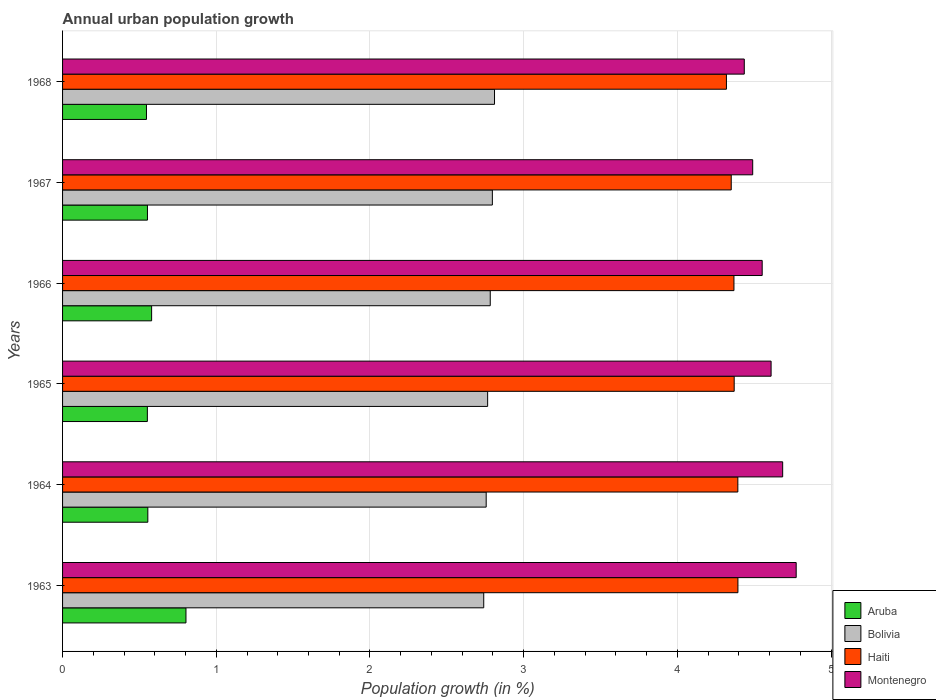Are the number of bars per tick equal to the number of legend labels?
Give a very brief answer. Yes. How many bars are there on the 6th tick from the top?
Make the answer very short. 4. What is the label of the 3rd group of bars from the top?
Give a very brief answer. 1966. What is the percentage of urban population growth in Aruba in 1966?
Ensure brevity in your answer.  0.58. Across all years, what is the maximum percentage of urban population growth in Aruba?
Ensure brevity in your answer.  0.8. Across all years, what is the minimum percentage of urban population growth in Bolivia?
Offer a very short reply. 2.74. In which year was the percentage of urban population growth in Aruba maximum?
Provide a succinct answer. 1963. In which year was the percentage of urban population growth in Haiti minimum?
Offer a very short reply. 1968. What is the total percentage of urban population growth in Montenegro in the graph?
Provide a short and direct response. 27.54. What is the difference between the percentage of urban population growth in Montenegro in 1964 and that in 1967?
Ensure brevity in your answer.  0.2. What is the difference between the percentage of urban population growth in Haiti in 1966 and the percentage of urban population growth in Montenegro in 1965?
Offer a very short reply. -0.24. What is the average percentage of urban population growth in Aruba per year?
Your answer should be very brief. 0.6. In the year 1968, what is the difference between the percentage of urban population growth in Aruba and percentage of urban population growth in Haiti?
Make the answer very short. -3.77. What is the ratio of the percentage of urban population growth in Montenegro in 1965 to that in 1966?
Your response must be concise. 1.01. Is the percentage of urban population growth in Bolivia in 1965 less than that in 1966?
Make the answer very short. Yes. What is the difference between the highest and the second highest percentage of urban population growth in Montenegro?
Offer a very short reply. 0.09. What is the difference between the highest and the lowest percentage of urban population growth in Aruba?
Provide a short and direct response. 0.26. In how many years, is the percentage of urban population growth in Bolivia greater than the average percentage of urban population growth in Bolivia taken over all years?
Your answer should be compact. 3. Is the sum of the percentage of urban population growth in Montenegro in 1965 and 1966 greater than the maximum percentage of urban population growth in Aruba across all years?
Ensure brevity in your answer.  Yes. Is it the case that in every year, the sum of the percentage of urban population growth in Aruba and percentage of urban population growth in Montenegro is greater than the sum of percentage of urban population growth in Haiti and percentage of urban population growth in Bolivia?
Your answer should be compact. No. What does the 1st bar from the top in 1963 represents?
Make the answer very short. Montenegro. What does the 3rd bar from the bottom in 1968 represents?
Provide a succinct answer. Haiti. Is it the case that in every year, the sum of the percentage of urban population growth in Haiti and percentage of urban population growth in Bolivia is greater than the percentage of urban population growth in Montenegro?
Your answer should be very brief. Yes. How many bars are there?
Provide a succinct answer. 24. Are all the bars in the graph horizontal?
Keep it short and to the point. Yes. How many years are there in the graph?
Your answer should be very brief. 6. What is the difference between two consecutive major ticks on the X-axis?
Give a very brief answer. 1. Does the graph contain any zero values?
Your response must be concise. No. Does the graph contain grids?
Your answer should be very brief. Yes. Where does the legend appear in the graph?
Provide a succinct answer. Bottom right. What is the title of the graph?
Provide a short and direct response. Annual urban population growth. What is the label or title of the X-axis?
Ensure brevity in your answer.  Population growth (in %). What is the label or title of the Y-axis?
Offer a terse response. Years. What is the Population growth (in %) in Aruba in 1963?
Make the answer very short. 0.8. What is the Population growth (in %) of Bolivia in 1963?
Offer a terse response. 2.74. What is the Population growth (in %) in Haiti in 1963?
Provide a short and direct response. 4.39. What is the Population growth (in %) in Montenegro in 1963?
Make the answer very short. 4.77. What is the Population growth (in %) of Aruba in 1964?
Give a very brief answer. 0.55. What is the Population growth (in %) of Bolivia in 1964?
Provide a short and direct response. 2.76. What is the Population growth (in %) in Haiti in 1964?
Make the answer very short. 4.39. What is the Population growth (in %) of Montenegro in 1964?
Make the answer very short. 4.69. What is the Population growth (in %) in Aruba in 1965?
Make the answer very short. 0.55. What is the Population growth (in %) in Bolivia in 1965?
Provide a short and direct response. 2.77. What is the Population growth (in %) in Haiti in 1965?
Give a very brief answer. 4.37. What is the Population growth (in %) of Montenegro in 1965?
Offer a terse response. 4.61. What is the Population growth (in %) of Aruba in 1966?
Offer a terse response. 0.58. What is the Population growth (in %) in Bolivia in 1966?
Offer a terse response. 2.78. What is the Population growth (in %) of Haiti in 1966?
Make the answer very short. 4.37. What is the Population growth (in %) of Montenegro in 1966?
Ensure brevity in your answer.  4.55. What is the Population growth (in %) of Aruba in 1967?
Ensure brevity in your answer.  0.55. What is the Population growth (in %) in Bolivia in 1967?
Your answer should be very brief. 2.8. What is the Population growth (in %) of Haiti in 1967?
Your response must be concise. 4.35. What is the Population growth (in %) in Montenegro in 1967?
Offer a very short reply. 4.49. What is the Population growth (in %) of Aruba in 1968?
Ensure brevity in your answer.  0.55. What is the Population growth (in %) in Bolivia in 1968?
Your answer should be compact. 2.81. What is the Population growth (in %) in Haiti in 1968?
Your answer should be very brief. 4.32. What is the Population growth (in %) of Montenegro in 1968?
Your answer should be very brief. 4.44. Across all years, what is the maximum Population growth (in %) in Aruba?
Offer a terse response. 0.8. Across all years, what is the maximum Population growth (in %) of Bolivia?
Keep it short and to the point. 2.81. Across all years, what is the maximum Population growth (in %) of Haiti?
Provide a succinct answer. 4.39. Across all years, what is the maximum Population growth (in %) in Montenegro?
Your answer should be compact. 4.77. Across all years, what is the minimum Population growth (in %) of Aruba?
Ensure brevity in your answer.  0.55. Across all years, what is the minimum Population growth (in %) in Bolivia?
Give a very brief answer. 2.74. Across all years, what is the minimum Population growth (in %) in Haiti?
Your response must be concise. 4.32. Across all years, what is the minimum Population growth (in %) in Montenegro?
Give a very brief answer. 4.44. What is the total Population growth (in %) of Aruba in the graph?
Your response must be concise. 3.59. What is the total Population growth (in %) in Bolivia in the graph?
Ensure brevity in your answer.  16.65. What is the total Population growth (in %) of Haiti in the graph?
Offer a very short reply. 26.19. What is the total Population growth (in %) of Montenegro in the graph?
Your answer should be compact. 27.54. What is the difference between the Population growth (in %) of Aruba in 1963 and that in 1964?
Your response must be concise. 0.25. What is the difference between the Population growth (in %) in Bolivia in 1963 and that in 1964?
Your answer should be very brief. -0.02. What is the difference between the Population growth (in %) in Haiti in 1963 and that in 1964?
Your answer should be compact. 0. What is the difference between the Population growth (in %) in Montenegro in 1963 and that in 1964?
Provide a succinct answer. 0.09. What is the difference between the Population growth (in %) in Aruba in 1963 and that in 1965?
Provide a short and direct response. 0.25. What is the difference between the Population growth (in %) in Bolivia in 1963 and that in 1965?
Keep it short and to the point. -0.03. What is the difference between the Population growth (in %) in Haiti in 1963 and that in 1965?
Ensure brevity in your answer.  0.02. What is the difference between the Population growth (in %) in Montenegro in 1963 and that in 1965?
Your answer should be compact. 0.16. What is the difference between the Population growth (in %) of Aruba in 1963 and that in 1966?
Give a very brief answer. 0.22. What is the difference between the Population growth (in %) of Bolivia in 1963 and that in 1966?
Make the answer very short. -0.04. What is the difference between the Population growth (in %) of Haiti in 1963 and that in 1966?
Keep it short and to the point. 0.03. What is the difference between the Population growth (in %) in Montenegro in 1963 and that in 1966?
Provide a short and direct response. 0.22. What is the difference between the Population growth (in %) of Aruba in 1963 and that in 1967?
Provide a short and direct response. 0.25. What is the difference between the Population growth (in %) of Bolivia in 1963 and that in 1967?
Offer a terse response. -0.06. What is the difference between the Population growth (in %) in Haiti in 1963 and that in 1967?
Give a very brief answer. 0.04. What is the difference between the Population growth (in %) in Montenegro in 1963 and that in 1967?
Offer a very short reply. 0.28. What is the difference between the Population growth (in %) of Aruba in 1963 and that in 1968?
Keep it short and to the point. 0.26. What is the difference between the Population growth (in %) of Bolivia in 1963 and that in 1968?
Provide a succinct answer. -0.07. What is the difference between the Population growth (in %) of Haiti in 1963 and that in 1968?
Your answer should be very brief. 0.07. What is the difference between the Population growth (in %) of Montenegro in 1963 and that in 1968?
Offer a terse response. 0.34. What is the difference between the Population growth (in %) of Aruba in 1964 and that in 1965?
Provide a short and direct response. 0. What is the difference between the Population growth (in %) in Bolivia in 1964 and that in 1965?
Provide a succinct answer. -0.01. What is the difference between the Population growth (in %) of Haiti in 1964 and that in 1965?
Make the answer very short. 0.02. What is the difference between the Population growth (in %) in Montenegro in 1964 and that in 1965?
Ensure brevity in your answer.  0.08. What is the difference between the Population growth (in %) of Aruba in 1964 and that in 1966?
Provide a succinct answer. -0.02. What is the difference between the Population growth (in %) in Bolivia in 1964 and that in 1966?
Your answer should be very brief. -0.03. What is the difference between the Population growth (in %) of Haiti in 1964 and that in 1966?
Your response must be concise. 0.03. What is the difference between the Population growth (in %) of Montenegro in 1964 and that in 1966?
Provide a short and direct response. 0.13. What is the difference between the Population growth (in %) in Aruba in 1964 and that in 1967?
Offer a very short reply. 0. What is the difference between the Population growth (in %) in Bolivia in 1964 and that in 1967?
Ensure brevity in your answer.  -0.04. What is the difference between the Population growth (in %) in Haiti in 1964 and that in 1967?
Make the answer very short. 0.04. What is the difference between the Population growth (in %) of Montenegro in 1964 and that in 1967?
Ensure brevity in your answer.  0.2. What is the difference between the Population growth (in %) in Aruba in 1964 and that in 1968?
Your answer should be very brief. 0.01. What is the difference between the Population growth (in %) of Bolivia in 1964 and that in 1968?
Provide a succinct answer. -0.05. What is the difference between the Population growth (in %) of Haiti in 1964 and that in 1968?
Provide a short and direct response. 0.07. What is the difference between the Population growth (in %) of Montenegro in 1964 and that in 1968?
Offer a very short reply. 0.25. What is the difference between the Population growth (in %) in Aruba in 1965 and that in 1966?
Offer a terse response. -0.03. What is the difference between the Population growth (in %) of Bolivia in 1965 and that in 1966?
Offer a terse response. -0.02. What is the difference between the Population growth (in %) of Haiti in 1965 and that in 1966?
Your answer should be compact. 0. What is the difference between the Population growth (in %) in Montenegro in 1965 and that in 1966?
Keep it short and to the point. 0.06. What is the difference between the Population growth (in %) in Aruba in 1965 and that in 1967?
Keep it short and to the point. -0. What is the difference between the Population growth (in %) of Bolivia in 1965 and that in 1967?
Ensure brevity in your answer.  -0.03. What is the difference between the Population growth (in %) in Haiti in 1965 and that in 1967?
Your response must be concise. 0.02. What is the difference between the Population growth (in %) of Montenegro in 1965 and that in 1967?
Your response must be concise. 0.12. What is the difference between the Population growth (in %) in Aruba in 1965 and that in 1968?
Your answer should be compact. 0.01. What is the difference between the Population growth (in %) in Bolivia in 1965 and that in 1968?
Your answer should be compact. -0.04. What is the difference between the Population growth (in %) of Haiti in 1965 and that in 1968?
Ensure brevity in your answer.  0.05. What is the difference between the Population growth (in %) in Montenegro in 1965 and that in 1968?
Give a very brief answer. 0.17. What is the difference between the Population growth (in %) in Aruba in 1966 and that in 1967?
Provide a short and direct response. 0.03. What is the difference between the Population growth (in %) in Bolivia in 1966 and that in 1967?
Your answer should be compact. -0.01. What is the difference between the Population growth (in %) of Haiti in 1966 and that in 1967?
Ensure brevity in your answer.  0.02. What is the difference between the Population growth (in %) of Montenegro in 1966 and that in 1967?
Make the answer very short. 0.06. What is the difference between the Population growth (in %) in Aruba in 1966 and that in 1968?
Your response must be concise. 0.03. What is the difference between the Population growth (in %) in Bolivia in 1966 and that in 1968?
Ensure brevity in your answer.  -0.03. What is the difference between the Population growth (in %) in Haiti in 1966 and that in 1968?
Provide a succinct answer. 0.05. What is the difference between the Population growth (in %) in Montenegro in 1966 and that in 1968?
Your answer should be compact. 0.12. What is the difference between the Population growth (in %) of Aruba in 1967 and that in 1968?
Offer a terse response. 0.01. What is the difference between the Population growth (in %) in Bolivia in 1967 and that in 1968?
Provide a succinct answer. -0.01. What is the difference between the Population growth (in %) in Haiti in 1967 and that in 1968?
Keep it short and to the point. 0.03. What is the difference between the Population growth (in %) of Montenegro in 1967 and that in 1968?
Ensure brevity in your answer.  0.05. What is the difference between the Population growth (in %) in Aruba in 1963 and the Population growth (in %) in Bolivia in 1964?
Your response must be concise. -1.95. What is the difference between the Population growth (in %) in Aruba in 1963 and the Population growth (in %) in Haiti in 1964?
Provide a short and direct response. -3.59. What is the difference between the Population growth (in %) of Aruba in 1963 and the Population growth (in %) of Montenegro in 1964?
Provide a short and direct response. -3.88. What is the difference between the Population growth (in %) in Bolivia in 1963 and the Population growth (in %) in Haiti in 1964?
Give a very brief answer. -1.65. What is the difference between the Population growth (in %) of Bolivia in 1963 and the Population growth (in %) of Montenegro in 1964?
Provide a succinct answer. -1.94. What is the difference between the Population growth (in %) of Haiti in 1963 and the Population growth (in %) of Montenegro in 1964?
Make the answer very short. -0.29. What is the difference between the Population growth (in %) in Aruba in 1963 and the Population growth (in %) in Bolivia in 1965?
Your answer should be compact. -1.96. What is the difference between the Population growth (in %) in Aruba in 1963 and the Population growth (in %) in Haiti in 1965?
Keep it short and to the point. -3.57. What is the difference between the Population growth (in %) of Aruba in 1963 and the Population growth (in %) of Montenegro in 1965?
Provide a short and direct response. -3.81. What is the difference between the Population growth (in %) of Bolivia in 1963 and the Population growth (in %) of Haiti in 1965?
Provide a succinct answer. -1.63. What is the difference between the Population growth (in %) in Bolivia in 1963 and the Population growth (in %) in Montenegro in 1965?
Offer a very short reply. -1.87. What is the difference between the Population growth (in %) in Haiti in 1963 and the Population growth (in %) in Montenegro in 1965?
Your answer should be compact. -0.22. What is the difference between the Population growth (in %) in Aruba in 1963 and the Population growth (in %) in Bolivia in 1966?
Offer a terse response. -1.98. What is the difference between the Population growth (in %) in Aruba in 1963 and the Population growth (in %) in Haiti in 1966?
Keep it short and to the point. -3.57. What is the difference between the Population growth (in %) of Aruba in 1963 and the Population growth (in %) of Montenegro in 1966?
Provide a succinct answer. -3.75. What is the difference between the Population growth (in %) of Bolivia in 1963 and the Population growth (in %) of Haiti in 1966?
Make the answer very short. -1.63. What is the difference between the Population growth (in %) of Bolivia in 1963 and the Population growth (in %) of Montenegro in 1966?
Give a very brief answer. -1.81. What is the difference between the Population growth (in %) of Haiti in 1963 and the Population growth (in %) of Montenegro in 1966?
Your response must be concise. -0.16. What is the difference between the Population growth (in %) in Aruba in 1963 and the Population growth (in %) in Bolivia in 1967?
Provide a succinct answer. -1.99. What is the difference between the Population growth (in %) in Aruba in 1963 and the Population growth (in %) in Haiti in 1967?
Offer a very short reply. -3.55. What is the difference between the Population growth (in %) of Aruba in 1963 and the Population growth (in %) of Montenegro in 1967?
Ensure brevity in your answer.  -3.69. What is the difference between the Population growth (in %) in Bolivia in 1963 and the Population growth (in %) in Haiti in 1967?
Offer a very short reply. -1.61. What is the difference between the Population growth (in %) of Bolivia in 1963 and the Population growth (in %) of Montenegro in 1967?
Keep it short and to the point. -1.75. What is the difference between the Population growth (in %) in Haiti in 1963 and the Population growth (in %) in Montenegro in 1967?
Ensure brevity in your answer.  -0.1. What is the difference between the Population growth (in %) of Aruba in 1963 and the Population growth (in %) of Bolivia in 1968?
Make the answer very short. -2.01. What is the difference between the Population growth (in %) of Aruba in 1963 and the Population growth (in %) of Haiti in 1968?
Keep it short and to the point. -3.52. What is the difference between the Population growth (in %) in Aruba in 1963 and the Population growth (in %) in Montenegro in 1968?
Provide a succinct answer. -3.63. What is the difference between the Population growth (in %) in Bolivia in 1963 and the Population growth (in %) in Haiti in 1968?
Offer a terse response. -1.58. What is the difference between the Population growth (in %) in Bolivia in 1963 and the Population growth (in %) in Montenegro in 1968?
Offer a terse response. -1.7. What is the difference between the Population growth (in %) of Haiti in 1963 and the Population growth (in %) of Montenegro in 1968?
Your answer should be very brief. -0.04. What is the difference between the Population growth (in %) of Aruba in 1964 and the Population growth (in %) of Bolivia in 1965?
Offer a terse response. -2.21. What is the difference between the Population growth (in %) in Aruba in 1964 and the Population growth (in %) in Haiti in 1965?
Your answer should be compact. -3.81. What is the difference between the Population growth (in %) of Aruba in 1964 and the Population growth (in %) of Montenegro in 1965?
Ensure brevity in your answer.  -4.05. What is the difference between the Population growth (in %) of Bolivia in 1964 and the Population growth (in %) of Haiti in 1965?
Offer a terse response. -1.61. What is the difference between the Population growth (in %) of Bolivia in 1964 and the Population growth (in %) of Montenegro in 1965?
Your response must be concise. -1.85. What is the difference between the Population growth (in %) in Haiti in 1964 and the Population growth (in %) in Montenegro in 1965?
Ensure brevity in your answer.  -0.22. What is the difference between the Population growth (in %) in Aruba in 1964 and the Population growth (in %) in Bolivia in 1966?
Offer a terse response. -2.23. What is the difference between the Population growth (in %) in Aruba in 1964 and the Population growth (in %) in Haiti in 1966?
Your answer should be very brief. -3.81. What is the difference between the Population growth (in %) in Aruba in 1964 and the Population growth (in %) in Montenegro in 1966?
Offer a terse response. -4. What is the difference between the Population growth (in %) of Bolivia in 1964 and the Population growth (in %) of Haiti in 1966?
Your response must be concise. -1.61. What is the difference between the Population growth (in %) of Bolivia in 1964 and the Population growth (in %) of Montenegro in 1966?
Provide a succinct answer. -1.8. What is the difference between the Population growth (in %) of Haiti in 1964 and the Population growth (in %) of Montenegro in 1966?
Offer a terse response. -0.16. What is the difference between the Population growth (in %) in Aruba in 1964 and the Population growth (in %) in Bolivia in 1967?
Your answer should be compact. -2.24. What is the difference between the Population growth (in %) in Aruba in 1964 and the Population growth (in %) in Haiti in 1967?
Keep it short and to the point. -3.8. What is the difference between the Population growth (in %) of Aruba in 1964 and the Population growth (in %) of Montenegro in 1967?
Your response must be concise. -3.94. What is the difference between the Population growth (in %) of Bolivia in 1964 and the Population growth (in %) of Haiti in 1967?
Provide a succinct answer. -1.59. What is the difference between the Population growth (in %) of Bolivia in 1964 and the Population growth (in %) of Montenegro in 1967?
Make the answer very short. -1.73. What is the difference between the Population growth (in %) of Haiti in 1964 and the Population growth (in %) of Montenegro in 1967?
Offer a very short reply. -0.1. What is the difference between the Population growth (in %) of Aruba in 1964 and the Population growth (in %) of Bolivia in 1968?
Provide a short and direct response. -2.26. What is the difference between the Population growth (in %) in Aruba in 1964 and the Population growth (in %) in Haiti in 1968?
Your response must be concise. -3.76. What is the difference between the Population growth (in %) in Aruba in 1964 and the Population growth (in %) in Montenegro in 1968?
Your answer should be very brief. -3.88. What is the difference between the Population growth (in %) in Bolivia in 1964 and the Population growth (in %) in Haiti in 1968?
Make the answer very short. -1.56. What is the difference between the Population growth (in %) of Bolivia in 1964 and the Population growth (in %) of Montenegro in 1968?
Give a very brief answer. -1.68. What is the difference between the Population growth (in %) in Haiti in 1964 and the Population growth (in %) in Montenegro in 1968?
Provide a succinct answer. -0.04. What is the difference between the Population growth (in %) of Aruba in 1965 and the Population growth (in %) of Bolivia in 1966?
Give a very brief answer. -2.23. What is the difference between the Population growth (in %) of Aruba in 1965 and the Population growth (in %) of Haiti in 1966?
Your response must be concise. -3.82. What is the difference between the Population growth (in %) in Aruba in 1965 and the Population growth (in %) in Montenegro in 1966?
Ensure brevity in your answer.  -4. What is the difference between the Population growth (in %) of Bolivia in 1965 and the Population growth (in %) of Haiti in 1966?
Offer a terse response. -1.6. What is the difference between the Population growth (in %) of Bolivia in 1965 and the Population growth (in %) of Montenegro in 1966?
Offer a very short reply. -1.79. What is the difference between the Population growth (in %) of Haiti in 1965 and the Population growth (in %) of Montenegro in 1966?
Provide a short and direct response. -0.18. What is the difference between the Population growth (in %) of Aruba in 1965 and the Population growth (in %) of Bolivia in 1967?
Give a very brief answer. -2.24. What is the difference between the Population growth (in %) in Aruba in 1965 and the Population growth (in %) in Haiti in 1967?
Your answer should be very brief. -3.8. What is the difference between the Population growth (in %) of Aruba in 1965 and the Population growth (in %) of Montenegro in 1967?
Provide a short and direct response. -3.94. What is the difference between the Population growth (in %) in Bolivia in 1965 and the Population growth (in %) in Haiti in 1967?
Your answer should be compact. -1.58. What is the difference between the Population growth (in %) in Bolivia in 1965 and the Population growth (in %) in Montenegro in 1967?
Give a very brief answer. -1.72. What is the difference between the Population growth (in %) of Haiti in 1965 and the Population growth (in %) of Montenegro in 1967?
Your answer should be very brief. -0.12. What is the difference between the Population growth (in %) of Aruba in 1965 and the Population growth (in %) of Bolivia in 1968?
Your answer should be very brief. -2.26. What is the difference between the Population growth (in %) in Aruba in 1965 and the Population growth (in %) in Haiti in 1968?
Your answer should be very brief. -3.77. What is the difference between the Population growth (in %) in Aruba in 1965 and the Population growth (in %) in Montenegro in 1968?
Your response must be concise. -3.88. What is the difference between the Population growth (in %) in Bolivia in 1965 and the Population growth (in %) in Haiti in 1968?
Your answer should be compact. -1.55. What is the difference between the Population growth (in %) of Bolivia in 1965 and the Population growth (in %) of Montenegro in 1968?
Provide a short and direct response. -1.67. What is the difference between the Population growth (in %) in Haiti in 1965 and the Population growth (in %) in Montenegro in 1968?
Make the answer very short. -0.07. What is the difference between the Population growth (in %) in Aruba in 1966 and the Population growth (in %) in Bolivia in 1967?
Your answer should be very brief. -2.22. What is the difference between the Population growth (in %) of Aruba in 1966 and the Population growth (in %) of Haiti in 1967?
Your response must be concise. -3.77. What is the difference between the Population growth (in %) of Aruba in 1966 and the Population growth (in %) of Montenegro in 1967?
Provide a succinct answer. -3.91. What is the difference between the Population growth (in %) in Bolivia in 1966 and the Population growth (in %) in Haiti in 1967?
Make the answer very short. -1.57. What is the difference between the Population growth (in %) in Bolivia in 1966 and the Population growth (in %) in Montenegro in 1967?
Make the answer very short. -1.71. What is the difference between the Population growth (in %) of Haiti in 1966 and the Population growth (in %) of Montenegro in 1967?
Make the answer very short. -0.12. What is the difference between the Population growth (in %) in Aruba in 1966 and the Population growth (in %) in Bolivia in 1968?
Your answer should be compact. -2.23. What is the difference between the Population growth (in %) in Aruba in 1966 and the Population growth (in %) in Haiti in 1968?
Offer a terse response. -3.74. What is the difference between the Population growth (in %) of Aruba in 1966 and the Population growth (in %) of Montenegro in 1968?
Provide a short and direct response. -3.86. What is the difference between the Population growth (in %) of Bolivia in 1966 and the Population growth (in %) of Haiti in 1968?
Your response must be concise. -1.54. What is the difference between the Population growth (in %) of Bolivia in 1966 and the Population growth (in %) of Montenegro in 1968?
Give a very brief answer. -1.65. What is the difference between the Population growth (in %) in Haiti in 1966 and the Population growth (in %) in Montenegro in 1968?
Offer a terse response. -0.07. What is the difference between the Population growth (in %) in Aruba in 1967 and the Population growth (in %) in Bolivia in 1968?
Give a very brief answer. -2.26. What is the difference between the Population growth (in %) in Aruba in 1967 and the Population growth (in %) in Haiti in 1968?
Offer a very short reply. -3.77. What is the difference between the Population growth (in %) in Aruba in 1967 and the Population growth (in %) in Montenegro in 1968?
Give a very brief answer. -3.88. What is the difference between the Population growth (in %) of Bolivia in 1967 and the Population growth (in %) of Haiti in 1968?
Give a very brief answer. -1.52. What is the difference between the Population growth (in %) of Bolivia in 1967 and the Population growth (in %) of Montenegro in 1968?
Make the answer very short. -1.64. What is the difference between the Population growth (in %) of Haiti in 1967 and the Population growth (in %) of Montenegro in 1968?
Make the answer very short. -0.08. What is the average Population growth (in %) of Aruba per year?
Your response must be concise. 0.6. What is the average Population growth (in %) of Bolivia per year?
Your answer should be compact. 2.78. What is the average Population growth (in %) of Haiti per year?
Give a very brief answer. 4.37. What is the average Population growth (in %) in Montenegro per year?
Your response must be concise. 4.59. In the year 1963, what is the difference between the Population growth (in %) in Aruba and Population growth (in %) in Bolivia?
Provide a succinct answer. -1.94. In the year 1963, what is the difference between the Population growth (in %) of Aruba and Population growth (in %) of Haiti?
Ensure brevity in your answer.  -3.59. In the year 1963, what is the difference between the Population growth (in %) in Aruba and Population growth (in %) in Montenegro?
Give a very brief answer. -3.97. In the year 1963, what is the difference between the Population growth (in %) in Bolivia and Population growth (in %) in Haiti?
Keep it short and to the point. -1.65. In the year 1963, what is the difference between the Population growth (in %) in Bolivia and Population growth (in %) in Montenegro?
Provide a short and direct response. -2.03. In the year 1963, what is the difference between the Population growth (in %) of Haiti and Population growth (in %) of Montenegro?
Provide a succinct answer. -0.38. In the year 1964, what is the difference between the Population growth (in %) of Aruba and Population growth (in %) of Bolivia?
Offer a terse response. -2.2. In the year 1964, what is the difference between the Population growth (in %) of Aruba and Population growth (in %) of Haiti?
Ensure brevity in your answer.  -3.84. In the year 1964, what is the difference between the Population growth (in %) of Aruba and Population growth (in %) of Montenegro?
Keep it short and to the point. -4.13. In the year 1964, what is the difference between the Population growth (in %) of Bolivia and Population growth (in %) of Haiti?
Offer a very short reply. -1.64. In the year 1964, what is the difference between the Population growth (in %) in Bolivia and Population growth (in %) in Montenegro?
Ensure brevity in your answer.  -1.93. In the year 1964, what is the difference between the Population growth (in %) of Haiti and Population growth (in %) of Montenegro?
Offer a very short reply. -0.29. In the year 1965, what is the difference between the Population growth (in %) in Aruba and Population growth (in %) in Bolivia?
Offer a very short reply. -2.21. In the year 1965, what is the difference between the Population growth (in %) in Aruba and Population growth (in %) in Haiti?
Offer a terse response. -3.82. In the year 1965, what is the difference between the Population growth (in %) of Aruba and Population growth (in %) of Montenegro?
Offer a terse response. -4.06. In the year 1965, what is the difference between the Population growth (in %) of Bolivia and Population growth (in %) of Haiti?
Ensure brevity in your answer.  -1.6. In the year 1965, what is the difference between the Population growth (in %) of Bolivia and Population growth (in %) of Montenegro?
Provide a succinct answer. -1.84. In the year 1965, what is the difference between the Population growth (in %) of Haiti and Population growth (in %) of Montenegro?
Keep it short and to the point. -0.24. In the year 1966, what is the difference between the Population growth (in %) in Aruba and Population growth (in %) in Bolivia?
Keep it short and to the point. -2.2. In the year 1966, what is the difference between the Population growth (in %) in Aruba and Population growth (in %) in Haiti?
Offer a very short reply. -3.79. In the year 1966, what is the difference between the Population growth (in %) in Aruba and Population growth (in %) in Montenegro?
Ensure brevity in your answer.  -3.97. In the year 1966, what is the difference between the Population growth (in %) of Bolivia and Population growth (in %) of Haiti?
Your response must be concise. -1.59. In the year 1966, what is the difference between the Population growth (in %) in Bolivia and Population growth (in %) in Montenegro?
Offer a terse response. -1.77. In the year 1966, what is the difference between the Population growth (in %) of Haiti and Population growth (in %) of Montenegro?
Your answer should be compact. -0.18. In the year 1967, what is the difference between the Population growth (in %) of Aruba and Population growth (in %) of Bolivia?
Ensure brevity in your answer.  -2.24. In the year 1967, what is the difference between the Population growth (in %) in Aruba and Population growth (in %) in Haiti?
Your response must be concise. -3.8. In the year 1967, what is the difference between the Population growth (in %) in Aruba and Population growth (in %) in Montenegro?
Your answer should be very brief. -3.94. In the year 1967, what is the difference between the Population growth (in %) in Bolivia and Population growth (in %) in Haiti?
Offer a very short reply. -1.55. In the year 1967, what is the difference between the Population growth (in %) of Bolivia and Population growth (in %) of Montenegro?
Your answer should be compact. -1.69. In the year 1967, what is the difference between the Population growth (in %) of Haiti and Population growth (in %) of Montenegro?
Your answer should be very brief. -0.14. In the year 1968, what is the difference between the Population growth (in %) in Aruba and Population growth (in %) in Bolivia?
Your response must be concise. -2.26. In the year 1968, what is the difference between the Population growth (in %) of Aruba and Population growth (in %) of Haiti?
Keep it short and to the point. -3.77. In the year 1968, what is the difference between the Population growth (in %) in Aruba and Population growth (in %) in Montenegro?
Offer a very short reply. -3.89. In the year 1968, what is the difference between the Population growth (in %) of Bolivia and Population growth (in %) of Haiti?
Offer a terse response. -1.51. In the year 1968, what is the difference between the Population growth (in %) of Bolivia and Population growth (in %) of Montenegro?
Offer a very short reply. -1.62. In the year 1968, what is the difference between the Population growth (in %) in Haiti and Population growth (in %) in Montenegro?
Make the answer very short. -0.12. What is the ratio of the Population growth (in %) of Aruba in 1963 to that in 1964?
Offer a terse response. 1.45. What is the ratio of the Population growth (in %) of Bolivia in 1963 to that in 1964?
Provide a short and direct response. 0.99. What is the ratio of the Population growth (in %) of Montenegro in 1963 to that in 1964?
Your response must be concise. 1.02. What is the ratio of the Population growth (in %) in Aruba in 1963 to that in 1965?
Offer a terse response. 1.46. What is the ratio of the Population growth (in %) in Haiti in 1963 to that in 1965?
Offer a terse response. 1.01. What is the ratio of the Population growth (in %) of Montenegro in 1963 to that in 1965?
Ensure brevity in your answer.  1.04. What is the ratio of the Population growth (in %) of Aruba in 1963 to that in 1966?
Offer a terse response. 1.39. What is the ratio of the Population growth (in %) of Bolivia in 1963 to that in 1966?
Provide a succinct answer. 0.98. What is the ratio of the Population growth (in %) of Haiti in 1963 to that in 1966?
Make the answer very short. 1.01. What is the ratio of the Population growth (in %) of Montenegro in 1963 to that in 1966?
Your answer should be very brief. 1.05. What is the ratio of the Population growth (in %) in Aruba in 1963 to that in 1967?
Ensure brevity in your answer.  1.45. What is the ratio of the Population growth (in %) of Bolivia in 1963 to that in 1967?
Your answer should be compact. 0.98. What is the ratio of the Population growth (in %) of Montenegro in 1963 to that in 1967?
Your response must be concise. 1.06. What is the ratio of the Population growth (in %) of Aruba in 1963 to that in 1968?
Offer a terse response. 1.47. What is the ratio of the Population growth (in %) of Bolivia in 1963 to that in 1968?
Provide a short and direct response. 0.97. What is the ratio of the Population growth (in %) in Haiti in 1963 to that in 1968?
Offer a very short reply. 1.02. What is the ratio of the Population growth (in %) in Montenegro in 1963 to that in 1968?
Your answer should be very brief. 1.08. What is the ratio of the Population growth (in %) of Aruba in 1964 to that in 1965?
Your answer should be compact. 1.01. What is the ratio of the Population growth (in %) of Haiti in 1964 to that in 1965?
Offer a very short reply. 1.01. What is the ratio of the Population growth (in %) of Montenegro in 1964 to that in 1965?
Your answer should be very brief. 1.02. What is the ratio of the Population growth (in %) of Aruba in 1964 to that in 1966?
Your answer should be compact. 0.96. What is the ratio of the Population growth (in %) in Bolivia in 1964 to that in 1966?
Your answer should be very brief. 0.99. What is the ratio of the Population growth (in %) of Montenegro in 1964 to that in 1966?
Your answer should be very brief. 1.03. What is the ratio of the Population growth (in %) of Bolivia in 1964 to that in 1967?
Offer a terse response. 0.99. What is the ratio of the Population growth (in %) in Haiti in 1964 to that in 1967?
Keep it short and to the point. 1.01. What is the ratio of the Population growth (in %) of Montenegro in 1964 to that in 1967?
Provide a succinct answer. 1.04. What is the ratio of the Population growth (in %) in Aruba in 1964 to that in 1968?
Ensure brevity in your answer.  1.02. What is the ratio of the Population growth (in %) in Bolivia in 1964 to that in 1968?
Offer a very short reply. 0.98. What is the ratio of the Population growth (in %) in Haiti in 1964 to that in 1968?
Make the answer very short. 1.02. What is the ratio of the Population growth (in %) of Montenegro in 1964 to that in 1968?
Make the answer very short. 1.06. What is the ratio of the Population growth (in %) of Aruba in 1965 to that in 1966?
Your answer should be compact. 0.95. What is the ratio of the Population growth (in %) of Bolivia in 1965 to that in 1966?
Your answer should be very brief. 0.99. What is the ratio of the Population growth (in %) in Montenegro in 1965 to that in 1966?
Make the answer very short. 1.01. What is the ratio of the Population growth (in %) in Montenegro in 1965 to that in 1967?
Give a very brief answer. 1.03. What is the ratio of the Population growth (in %) in Aruba in 1965 to that in 1968?
Offer a very short reply. 1.01. What is the ratio of the Population growth (in %) in Bolivia in 1965 to that in 1968?
Your answer should be very brief. 0.98. What is the ratio of the Population growth (in %) in Haiti in 1965 to that in 1968?
Provide a succinct answer. 1.01. What is the ratio of the Population growth (in %) of Montenegro in 1965 to that in 1968?
Provide a succinct answer. 1.04. What is the ratio of the Population growth (in %) in Aruba in 1966 to that in 1967?
Keep it short and to the point. 1.05. What is the ratio of the Population growth (in %) of Bolivia in 1966 to that in 1967?
Your response must be concise. 1. What is the ratio of the Population growth (in %) in Montenegro in 1966 to that in 1967?
Your answer should be compact. 1.01. What is the ratio of the Population growth (in %) of Aruba in 1966 to that in 1968?
Offer a terse response. 1.06. What is the ratio of the Population growth (in %) in Bolivia in 1966 to that in 1968?
Provide a succinct answer. 0.99. What is the ratio of the Population growth (in %) in Haiti in 1966 to that in 1968?
Ensure brevity in your answer.  1.01. What is the ratio of the Population growth (in %) of Montenegro in 1966 to that in 1968?
Your answer should be very brief. 1.03. What is the ratio of the Population growth (in %) of Aruba in 1967 to that in 1968?
Your response must be concise. 1.01. What is the ratio of the Population growth (in %) in Bolivia in 1967 to that in 1968?
Your answer should be compact. 0.99. What is the ratio of the Population growth (in %) in Haiti in 1967 to that in 1968?
Keep it short and to the point. 1.01. What is the ratio of the Population growth (in %) in Montenegro in 1967 to that in 1968?
Your response must be concise. 1.01. What is the difference between the highest and the second highest Population growth (in %) of Aruba?
Ensure brevity in your answer.  0.22. What is the difference between the highest and the second highest Population growth (in %) of Bolivia?
Your answer should be very brief. 0.01. What is the difference between the highest and the second highest Population growth (in %) in Haiti?
Make the answer very short. 0. What is the difference between the highest and the second highest Population growth (in %) in Montenegro?
Give a very brief answer. 0.09. What is the difference between the highest and the lowest Population growth (in %) of Aruba?
Offer a terse response. 0.26. What is the difference between the highest and the lowest Population growth (in %) in Bolivia?
Your response must be concise. 0.07. What is the difference between the highest and the lowest Population growth (in %) in Haiti?
Make the answer very short. 0.07. What is the difference between the highest and the lowest Population growth (in %) of Montenegro?
Provide a short and direct response. 0.34. 